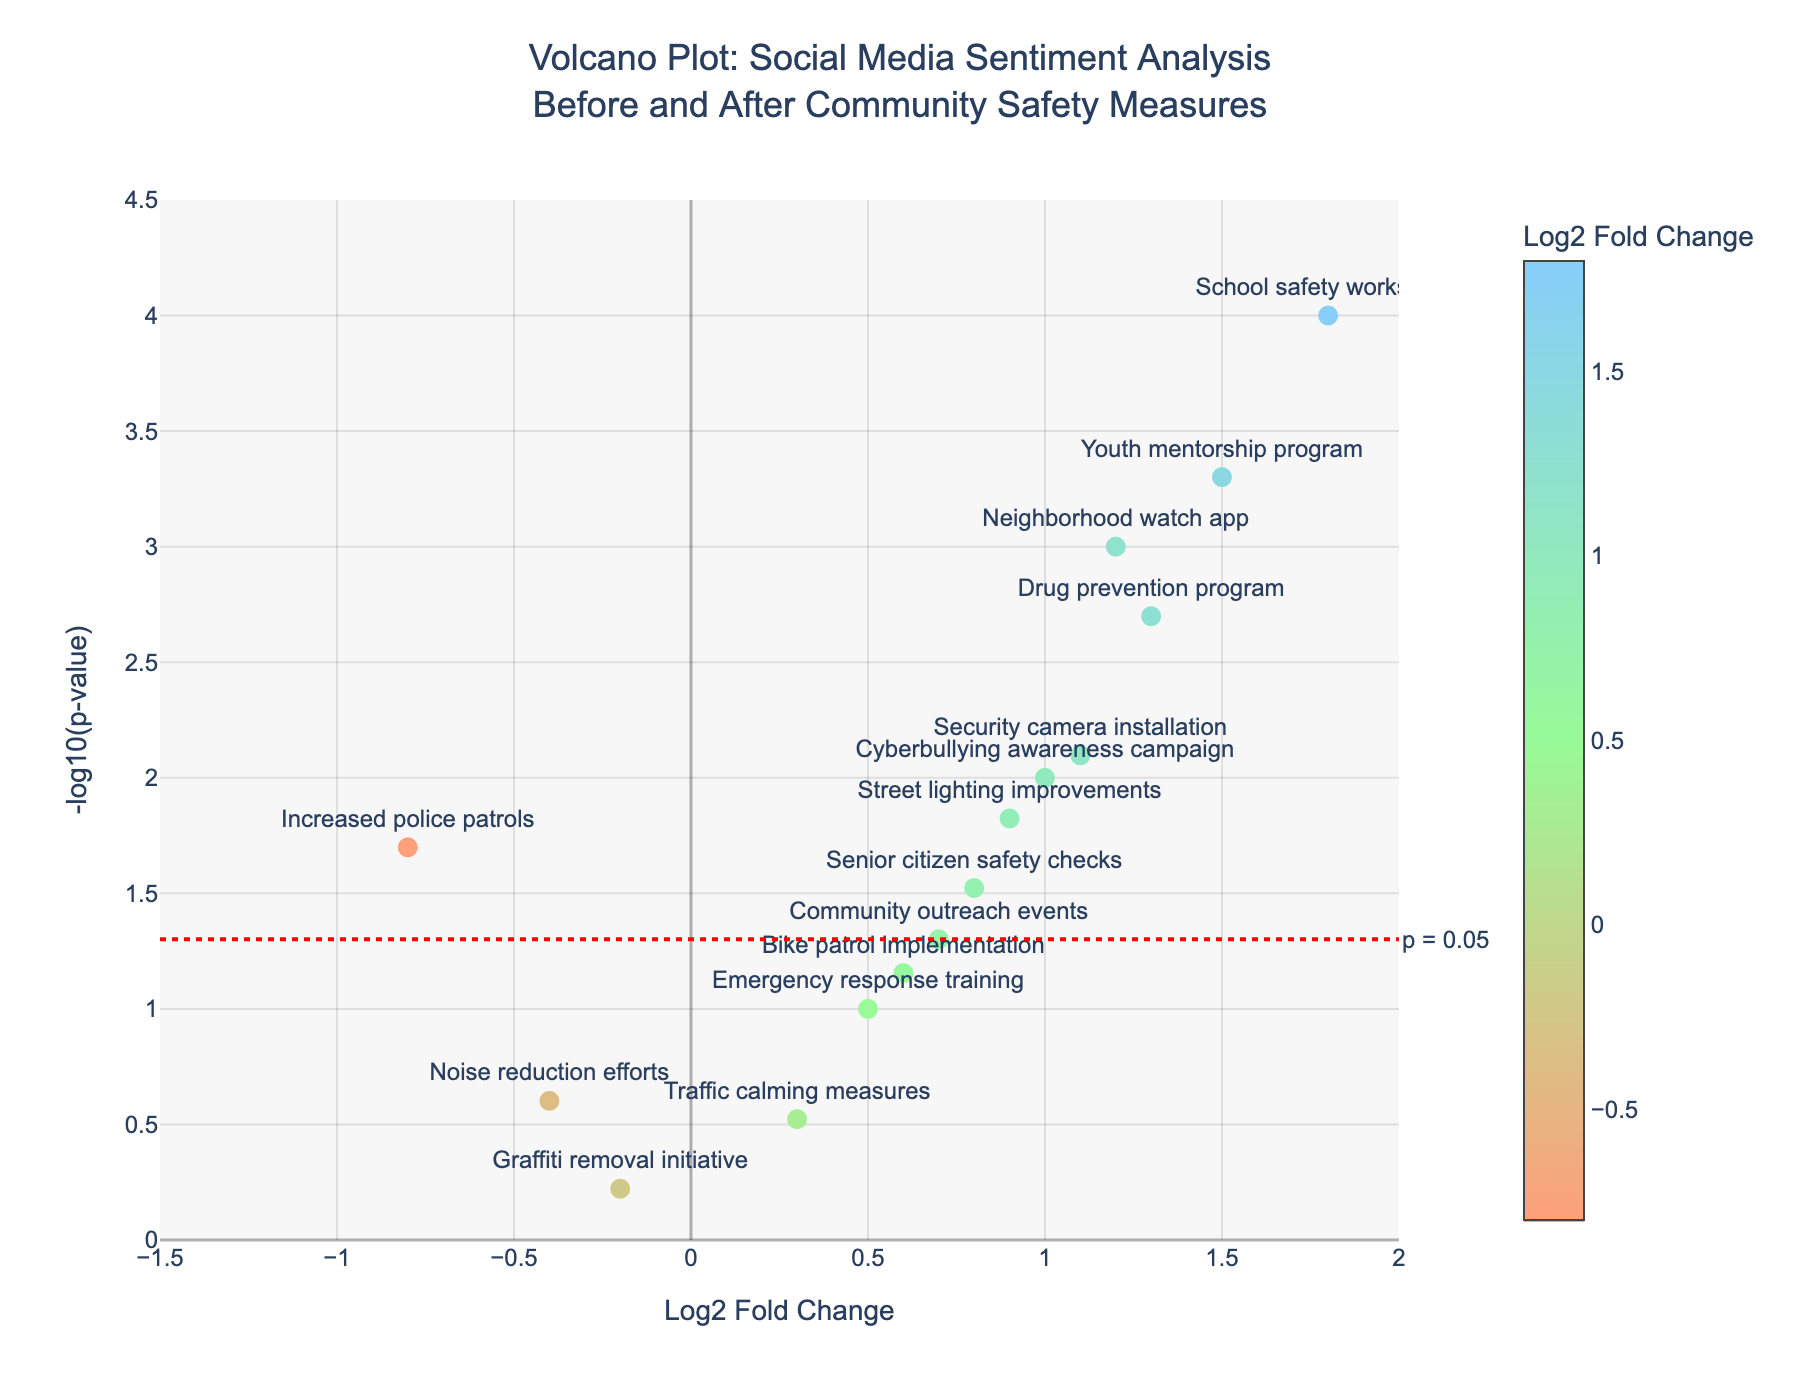What is the title of the plot? The title of the plot is typically found at the top of the chart. Reading from the top of the figure, the title is "Volcano Plot: Social Media Sentiment Analysis Before and After Community Safety Measures".
Answer: Volcano Plot: Social Media Sentiment Analysis Before and After Community Safety Measures What does the x-axis represent? The x-axis is usually labeled along the bottom of the plot. It shows "Log2 Fold Change", indicating changes in social media sentiment, with positive values indicating an increase and negative values indicating a decrease.
Answer: Log2 Fold Change What does the y-axis represent? The y-axis is labeled along the left side of the plot and shows "-log10(p-value)", representing the significance of the sentiment changes, with higher values indicating more significant results.
Answer: -log10(p-value) Which measure has the highest -log10(p-value)? From the plot, identify the point positioned highest on the y-axis. "School safety workshops" is the highest, indicating it has the most significant p-value.
Answer: School safety workshops Which measures fall below the significance threshold (p = 0.05)? The significance threshold is marked by the red horizontal line. Data points below this line are "Traffic calming measures", "Graffiti removal initiative", and "Noise reduction efforts".
Answer: Traffic calming measures, Graffiti removal initiative, Noise reduction efforts How many measures have a positive Log2 Fold Change and are significant (p < 0.05)? Locate the points with a positive Log2 Fold Change (right side of the plot) and check if they are above the red significance line. The measures are "Neighborhood watch app", "Street lighting improvements", "Youth mentorship program", "Security camera installation", "School safety workshops", "Drug prevention program", and "Cyberbullying awareness campaign".
Answer: 7 Which measure has the lowest Log2 Fold Change but is still significant (p < 0.05)? To find this, identify the points with a negative Log2 Fold Change and check those above the red significance line. "Increased police patrols" is the only one that satisfies both conditions.
Answer: Increased police patrols Compare "Neighborhood watch app" and "Security camera installation". Which has a greater impact on social media sentiment? Both measures have positive Log2 Fold Changes, but "Neighborhood watch app" is further to the right, indicating a higher Log2 Fold Change.
Answer: Neighborhood watch app What can be inferred about "Emergency response training" based on its position on the plot? "Emergency response training" is positioned slightly above the red line with a positive Log2 Fold Change. This indicates a moderate increase in social media sentiment that is close to being statistically significant.
Answer: Moderate increase, close to significant Which measure with a positive Log2 Fold Change has the smallest -log10(p-value)? Examine points with positive Log2 Fold changes and find the one with the lowest value on the y-axis. "Community outreach events" is the lowest among them.
Answer: Community outreach events 